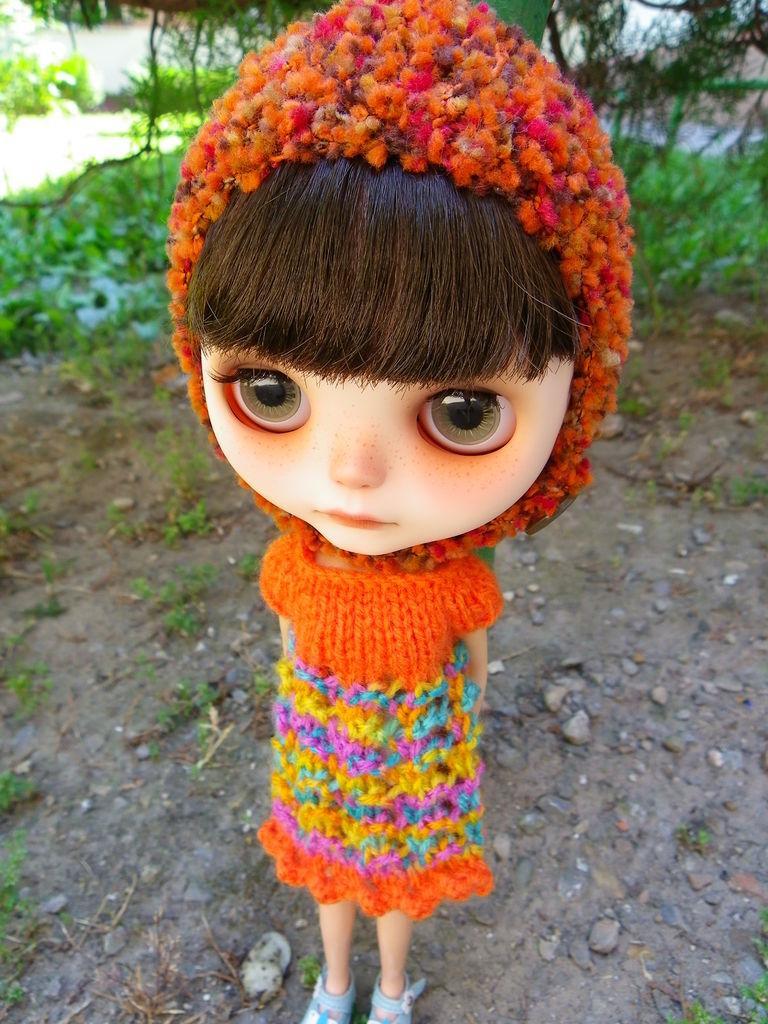Please provide a concise description of this image. In the center of the image we can see a doll. In the background of the image we can see the ground, stones, plants and trees. 